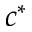Convert formula to latex. <formula><loc_0><loc_0><loc_500><loc_500>c ^ { * }</formula> 